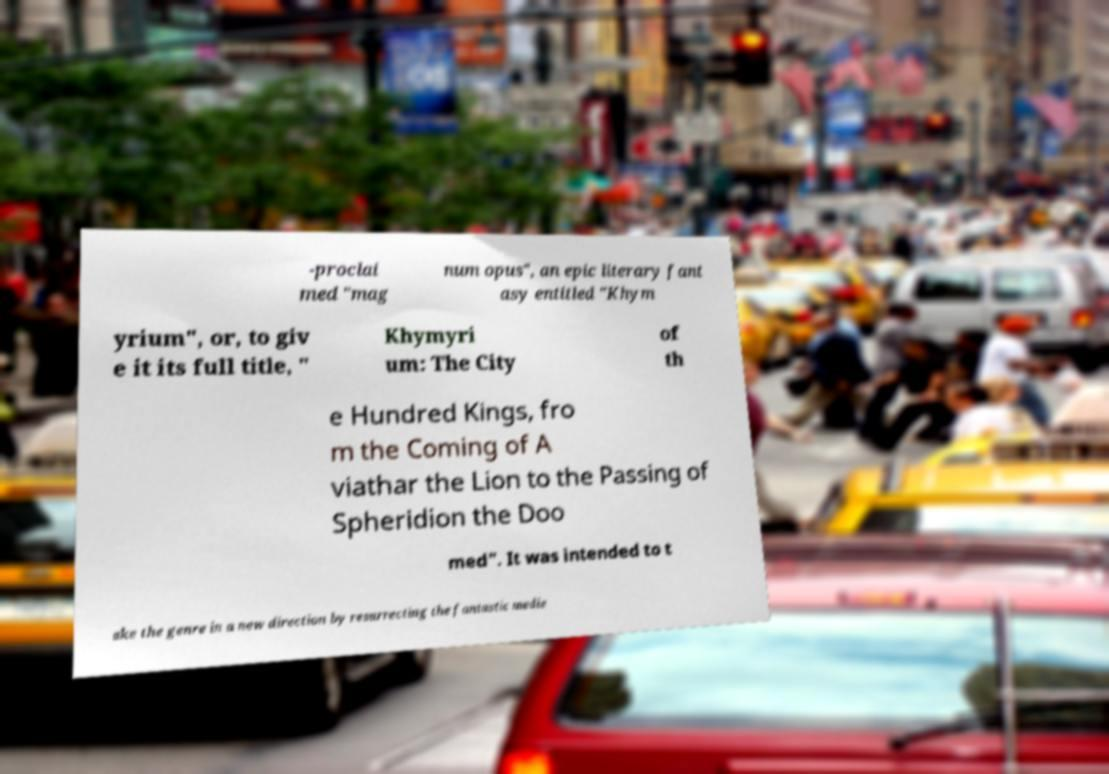Can you accurately transcribe the text from the provided image for me? -proclai med "mag num opus", an epic literary fant asy entitled "Khym yrium", or, to giv e it its full title, " Khymyri um: The City of th e Hundred Kings, fro m the Coming of A viathar the Lion to the Passing of Spheridion the Doo med". It was intended to t ake the genre in a new direction by resurrecting the fantastic medie 